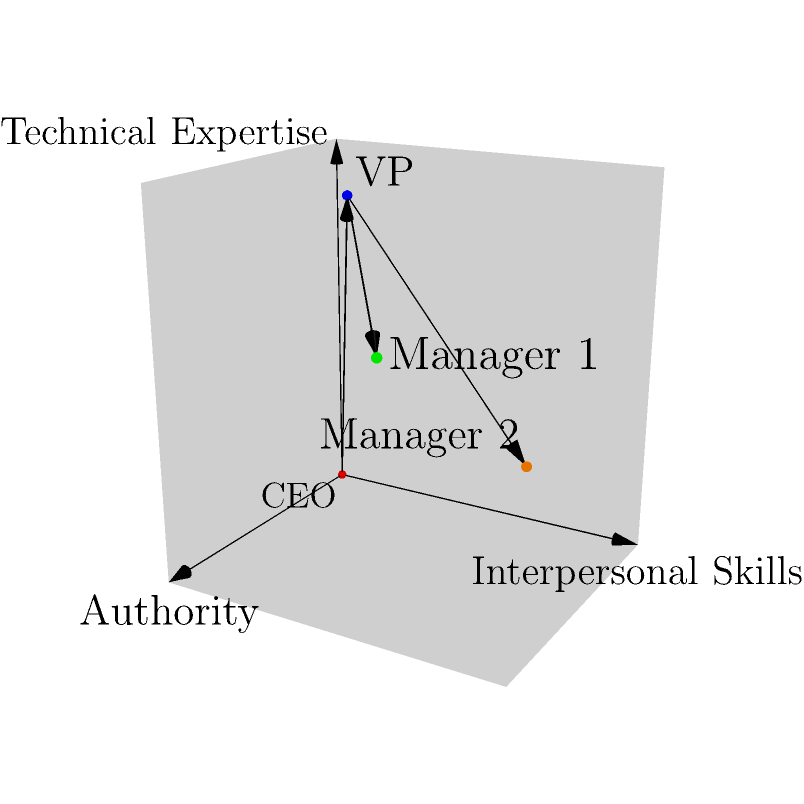In this 3D coordinate system representing leadership attributes, the x-axis represents authority, the y-axis represents interpersonal skills, and the z-axis represents technical expertise. Each point represents a leader in the organization. Based on the visualization, which leader has the highest level of technical expertise but the lowest level of authority? To answer this question, we need to analyze the position of each point in the 3D coordinate system:

1. First, identify all the leaders:
   - Red dot at (0,0,0): CEO
   - Blue dot at (0.3,0.2,0.9): VP
   - Green dot at (0.7,0.5,0.6): Manager 1
   - Orange dot at (0.4,0.8,0.3): Manager 2

2. Compare the z-coordinates (technical expertise):
   - CEO: 0
   - VP: 0.9
   - Manager 1: 0.6
   - Manager 2: 0.3

   The VP has the highest z-coordinate, indicating the highest technical expertise.

3. Compare the x-coordinates (authority):
   - CEO: 0
   - VP: 0.3
   - Manager 1: 0.7
   - Manager 2: 0.4

   The VP has the second-lowest x-coordinate, higher only than the CEO.

4. Considering both factors, the VP has the highest technical expertise (z-axis) while having a relatively low level of authority (x-axis) compared to the managers.

Therefore, the VP (blue dot) best fits the description of having the highest level of technical expertise but a lower level of authority compared to other leaders (except the CEO).
Answer: VP (blue dot) 